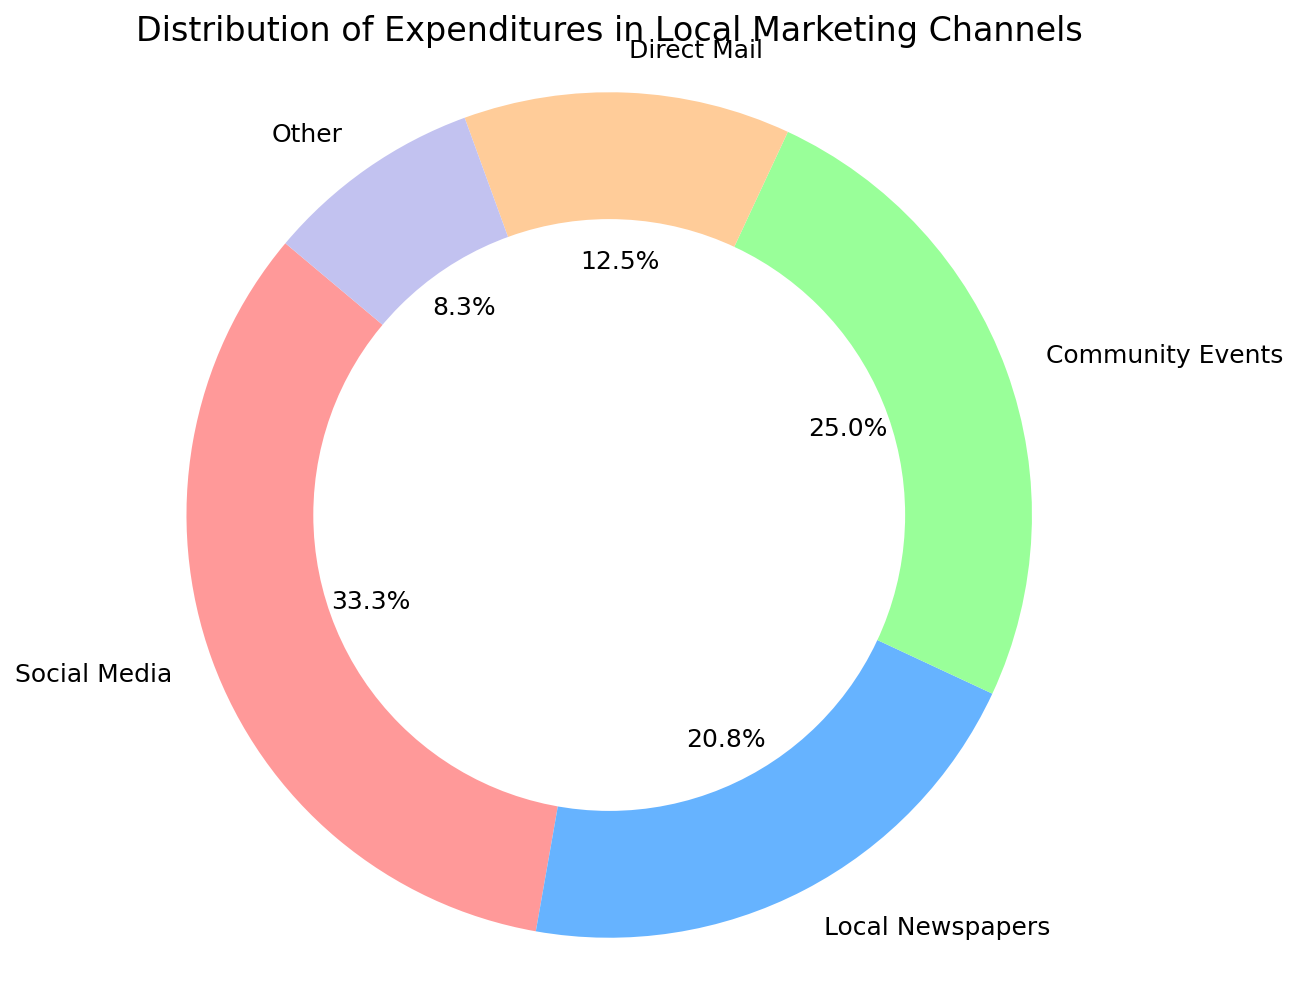what percentage of the expenditures is attributed to direct mail? In the pie chart, direct mail is represented by one of the slices. The label on this slice indicates its percentage contribution. From the figure, we can directly see that direct mail accounts for 15.0% of the total expenditures.
Answer: 15.0% what is the total expenditure for community events and local newspapers combined? From the pie chart, we see that the expenditures for community events and local newspapers are represented by their respective slices. The labels indicate these values are $3000 and $2500 respectively. Summing these amounts, we get $3000 + $2500 = $5500.
Answer: $5500 what is the smallest expenditure category and how much was spent on it? By examining the slices of the pie chart and their labeled percentages, we can identify that "Other" is the smallest category. The expenditure for "Other" is indicated as $1000.
Answer: Other, $1000 which marketing channel has the second highest expenditure? Observing the pie chart, we note that social media has the highest expenditure. By looking at the sizes and comparing the labels, we see that community events have the second largest slice after social media.
Answer: Community Events what is the difference in expenditure between social media and direct mail? Referring to the pie chart, social media expenditure is $4000 and direct mail expenditure is $1500. Subtracting these values, we get $4000 - $1500 = $2500.
Answer: $2500 amongst the given expenditures, how much more is spent on community events compared to other? Looking at the pie chart's labels, community events expenditure is $3000 while other is $1000. Subtracting these, we get $3000 - $1000 = $2000.
Answer: $2000 what proportion of the expenditures go to local newspapers and direct mail combined? The pie chart labels show local newspapers expenditure as $2500 and direct mail as $1500. Adding these gives $2500 + $1500 = $4000. The total expenditures sum to $12000, so the proportion is $4000 / $12000 = 0.333 or 33.3%.
Answer: 33.3% compared to direct mail, how many times larger is the expenditure on social media? The expenditure for social media is $4000 and for direct mail is $1500. Dividing these values, we get $4000 / $1500 ≈ 2.67, which means social media expenditure is approximately 2.67 times larger than direct mail expenditure.
Answer: 2.67 how does the expenditure on local newspapers compare to that on other? From the pie chart, the expenditure on local newspapers is $2500 and on other it is $1000. Comparing these, local newspapers have 2.5 times the expenditure of other channels ($2500 / $1000 = 2.5).
Answer: 2.5 times 